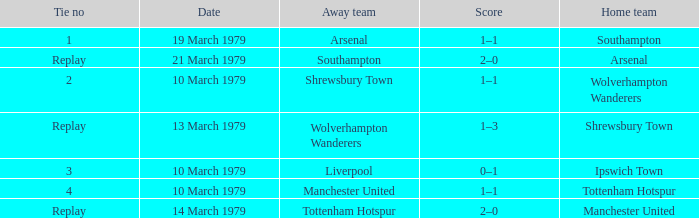Can you give me this table as a dict? {'header': ['Tie no', 'Date', 'Away team', 'Score', 'Home team'], 'rows': [['1', '19 March 1979', 'Arsenal', '1–1', 'Southampton'], ['Replay', '21 March 1979', 'Southampton', '2–0', 'Arsenal'], ['2', '10 March 1979', 'Shrewsbury Town', '1–1', 'Wolverhampton Wanderers'], ['Replay', '13 March 1979', 'Wolverhampton Wanderers', '1–3', 'Shrewsbury Town'], ['3', '10 March 1979', 'Liverpool', '0–1', 'Ipswich Town'], ['4', '10 March 1979', 'Manchester United', '1–1', 'Tottenham Hotspur'], ['Replay', '14 March 1979', 'Tottenham Hotspur', '2–0', 'Manchester United']]} Which tie number had an away team of Arsenal? 1.0. 